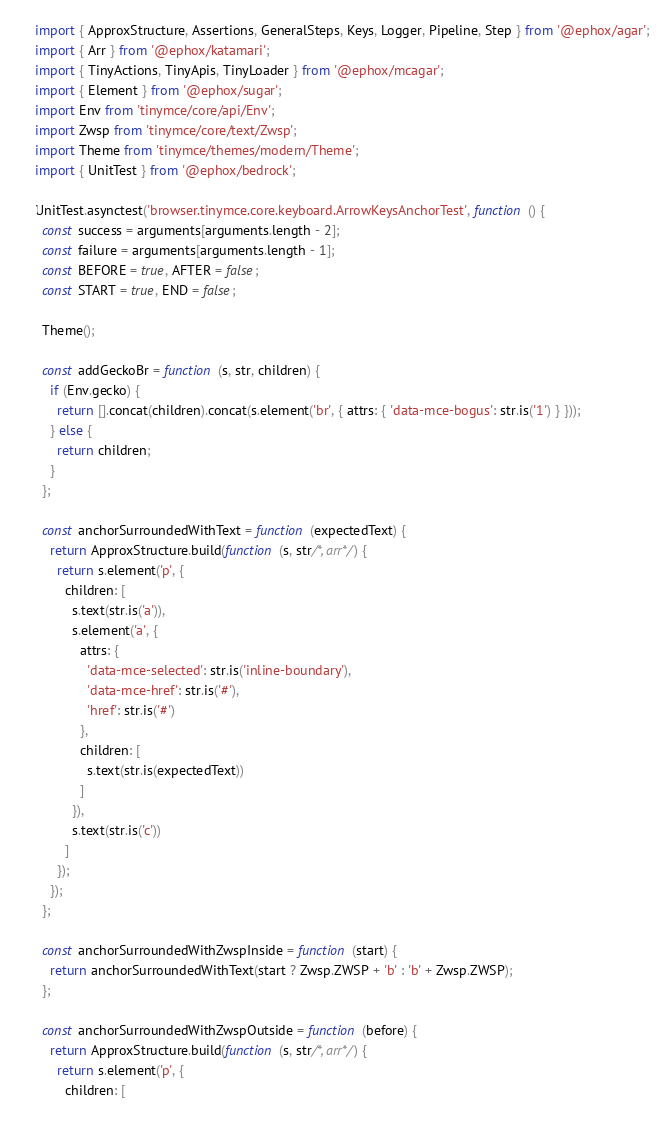<code> <loc_0><loc_0><loc_500><loc_500><_TypeScript_>import { ApproxStructure, Assertions, GeneralSteps, Keys, Logger, Pipeline, Step } from '@ephox/agar';
import { Arr } from '@ephox/katamari';
import { TinyActions, TinyApis, TinyLoader } from '@ephox/mcagar';
import { Element } from '@ephox/sugar';
import Env from 'tinymce/core/api/Env';
import Zwsp from 'tinymce/core/text/Zwsp';
import Theme from 'tinymce/themes/modern/Theme';
import { UnitTest } from '@ephox/bedrock';

UnitTest.asynctest('browser.tinymce.core.keyboard.ArrowKeysAnchorTest', function () {
  const success = arguments[arguments.length - 2];
  const failure = arguments[arguments.length - 1];
  const BEFORE = true, AFTER = false;
  const START = true, END = false;

  Theme();

  const addGeckoBr = function (s, str, children) {
    if (Env.gecko) {
      return [].concat(children).concat(s.element('br', { attrs: { 'data-mce-bogus': str.is('1') } }));
    } else {
      return children;
    }
  };

  const anchorSurroundedWithText = function (expectedText) {
    return ApproxStructure.build(function (s, str/*, arr*/) {
      return s.element('p', {
        children: [
          s.text(str.is('a')),
          s.element('a', {
            attrs: {
              'data-mce-selected': str.is('inline-boundary'),
              'data-mce-href': str.is('#'),
              'href': str.is('#')
            },
            children: [
              s.text(str.is(expectedText))
            ]
          }),
          s.text(str.is('c'))
        ]
      });
    });
  };

  const anchorSurroundedWithZwspInside = function (start) {
    return anchorSurroundedWithText(start ? Zwsp.ZWSP + 'b' : 'b' + Zwsp.ZWSP);
  };

  const anchorSurroundedWithZwspOutside = function (before) {
    return ApproxStructure.build(function (s, str/*, arr*/) {
      return s.element('p', {
        children: [</code> 